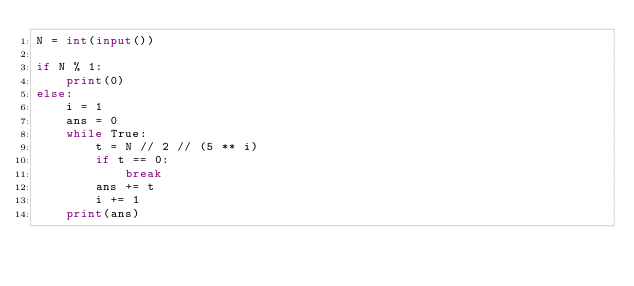Convert code to text. <code><loc_0><loc_0><loc_500><loc_500><_Python_>N = int(input())

if N % 1:
    print(0)
else:
    i = 1
    ans = 0
    while True:
        t = N // 2 // (5 ** i)
        if t == 0:
            break
        ans += t
        i += 1
    print(ans)</code> 